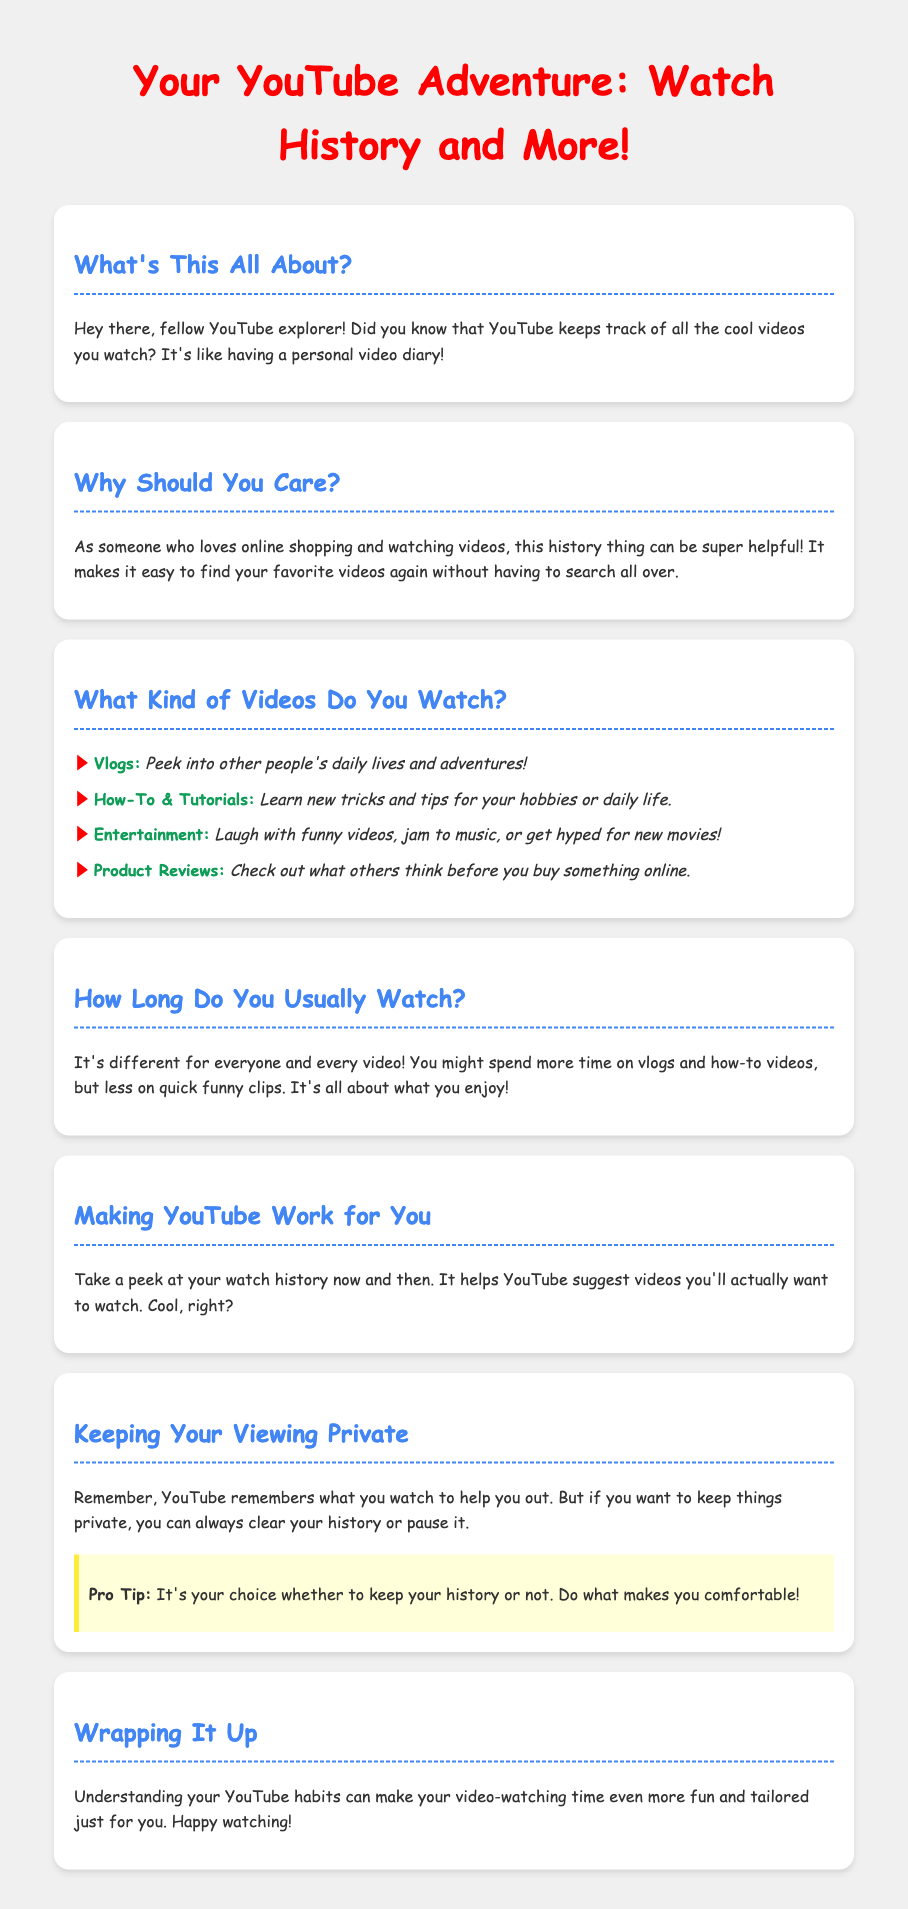What are the types of videos mentioned? The document lists four types of videos: Vlogs, How-To & Tutorials, Entertainment, and Product Reviews.
Answer: Vlogs, How-To & Tutorials, Entertainment, Product Reviews What is the tone of the document? The document uses a friendly and casual tone to engage readers about their YouTube habits.
Answer: Friendly and casual How does watching history help users? The document states that watch history helps YouTube suggest videos users would want to watch.
Answer: Suggest videos What is the purpose of clearing watch history? Clearing watch history is a way to keep viewing private if users choose to do so.
Answer: Keep viewing private Is there a specific style or font used in the document? The document uses 'Comic Sans MS' for its font style to create a casual and approachable look.
Answer: Comic Sans MS What should users do if they want to keep their viewing private? Users can either clear their history or pause it to maintain privacy.
Answer: Clear history or pause How does average watch time vary? Average watch time can differ between types of videos, like spending more time on vlogs and how-to videos.
Answer: Differ by video type What is suggested for YouTube users about the watch history? Users are encouraged to check their watch history now and then for a tailored experience.
Answer: Check watch history 